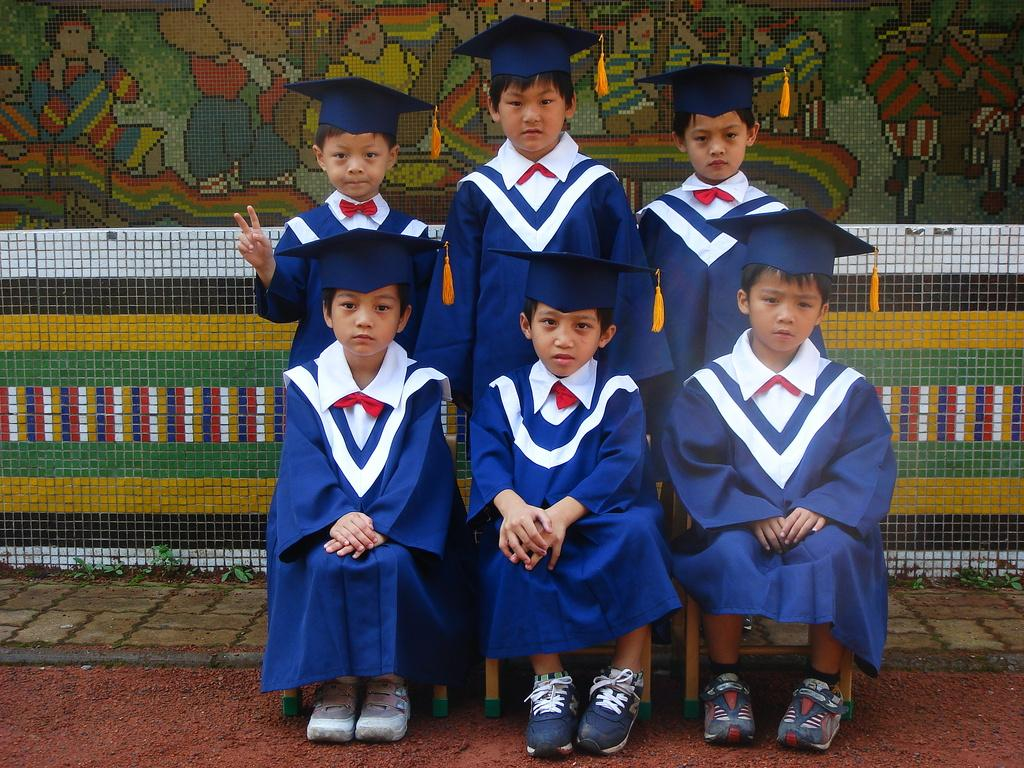What is the main subject of the image? The main subject of the image is kids. What are the kids doing in the image? Some kids are sitting on chairs, while others are standing. What can be seen in the background of the image? There is a fence and a painting on the wall visible in the background. What type of canvas is being used by the giants in the image? There are no giants present in the image, so there is no canvas being used by them. 